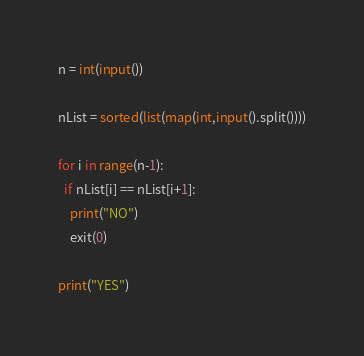<code> <loc_0><loc_0><loc_500><loc_500><_Python_>n = int(input())

nList = sorted(list(map(int,input().split())))

for i in range(n-1):
  if nList[i] == nList[i+1]:
    print("NO")
    exit(0)

print("YES")

</code> 